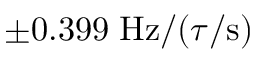<formula> <loc_0><loc_0><loc_500><loc_500>\pm 0 . 3 9 9 \, H z / ( \tau / s )</formula> 